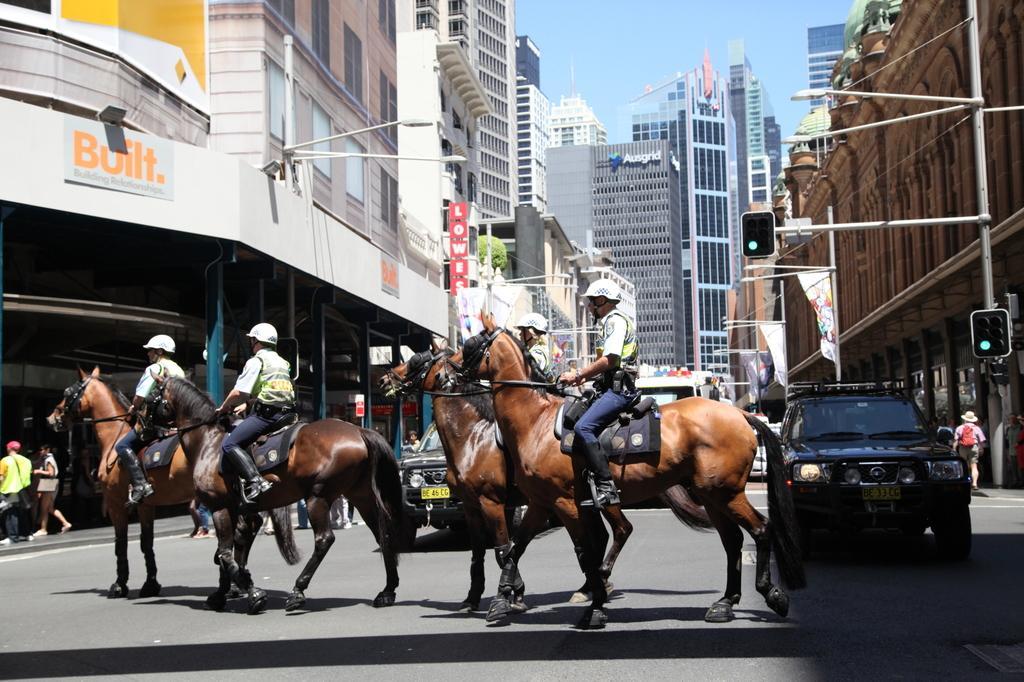Describe this image in one or two sentences. In this picture we can see some people riding the horses on the road and on the road there are vehicles and some people are walking. On the right side of the horses there are poles with traffic signals, banners and lights. Behind the horses there are buildings, plant and a sky. 